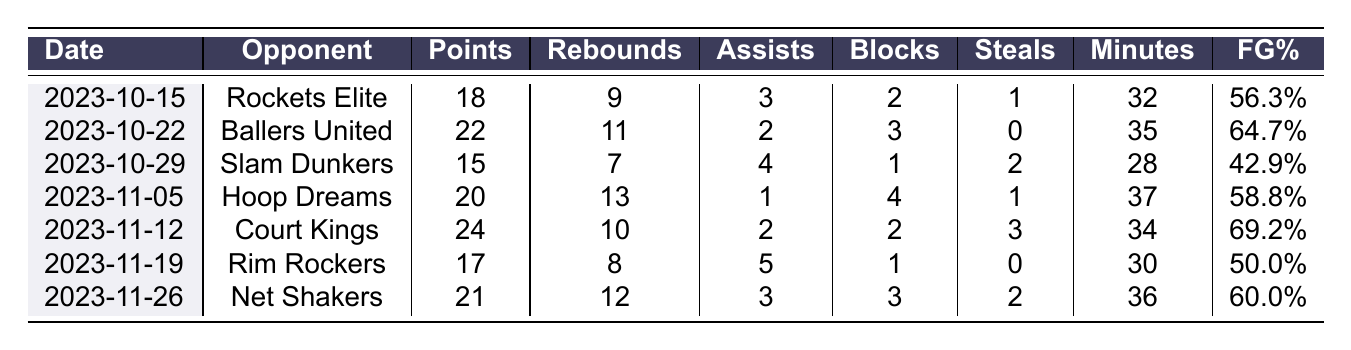What was Devonte Upson's highest points scored in a game? The table shows various games, and by looking through the points column, the highest points scored is 24 against Court Kings on 2023-11-12.
Answer: 24 In which game did Devonte Upson have the most rebounds? Checking the rebounds column, the highest number of rebounds is 13, which occurred in the game against Hoop Dreams on 2023-11-05.
Answer: 13 What is the average points per game for Devonte Upson over these games? To find the average, first sum the points: (18 + 22 + 15 + 20 + 24 + 17 + 21) = 137. There are 7 games, so the average is 137 / 7 = 19.57.
Answer: 19.57 Did he ever achieve a field goal percentage greater than 60%? By examining the field goal percentage column, there are three instances (64.7%, 69.2%, and 60.0%) where his percentage exceeds 60%.
Answer: Yes Which game had the most minutes played by Devonte Upson? Looking at the minutes played column, the highest value is 37 minutes, which was during the game against Hoop Dreams on 2023-11-05.
Answer: 37 How many blocks did he accumulate across all games? To find the total blocks, add up the blocks from each game: (2 + 3 + 1 + 4 + 2 + 1 + 3) = 16.
Answer: 16 Which opponent had the least points scored by Devonte Upson? The table shows the points scored against each opponent; the least was 15 points against Slam Dunkers on 2023-10-29.
Answer: 15 What is the total number of assists recorded by Devonte Upson throughout these games? To find total assists, sum them: (3 + 2 + 4 + 1 + 2 + 5 + 3) = 20.
Answer: 20 In how many games did he score more than 20 points? By checking the points column, he scored more than 20 points in 4 games: against Ballers United, Hoop Dreams, Court Kings, and Net Shakers.
Answer: 4 What was his average number of steals per game? The total steals are calculated: (1 + 0 + 2 + 1 + 3 + 0 + 2) = 9. Then divide by the number of games: 9 / 7 = 1.29.
Answer: 1.29 